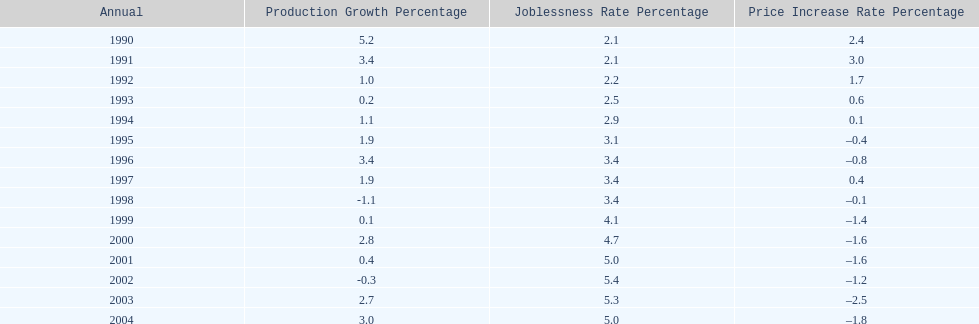In what years, between 1990 and 2004, did japan's unemployment rate reach 5% or higher? 4. 